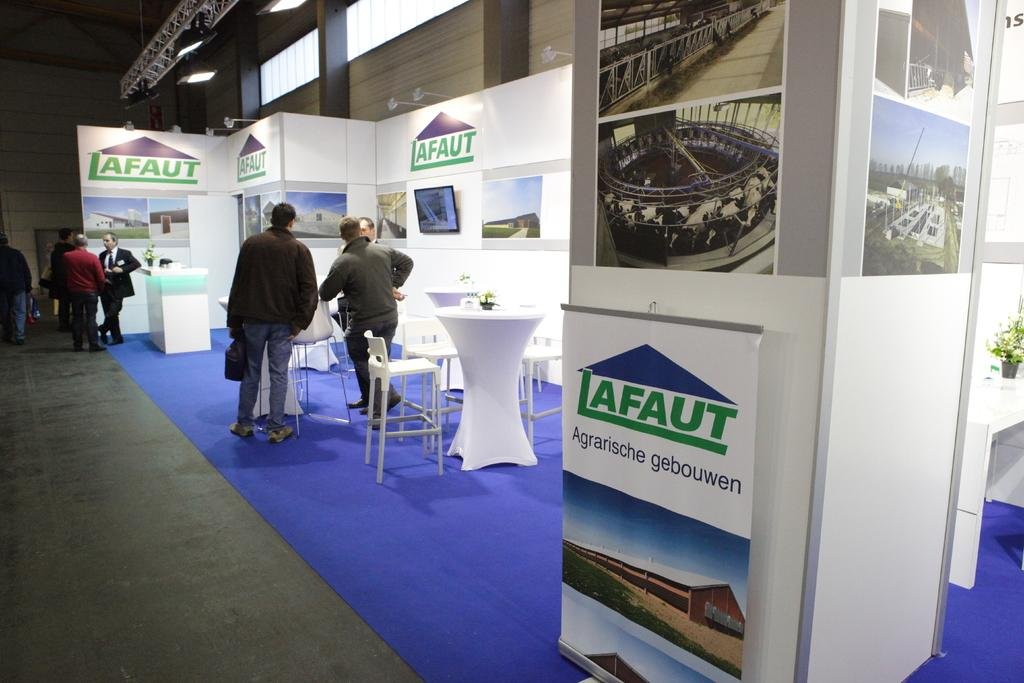Provide a one-sentence caption for the provided image. some people at an event with the name Lafaut  in the title. 